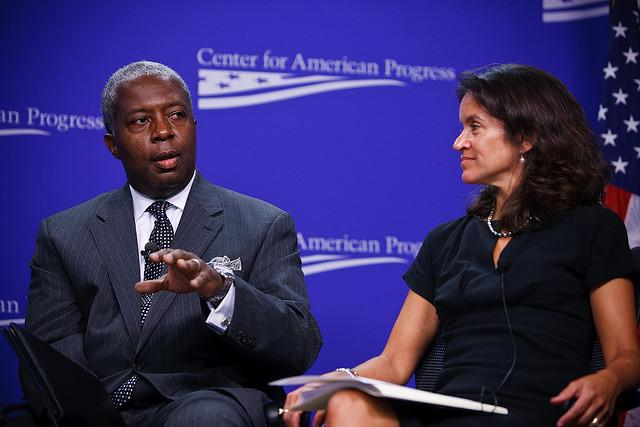What type talk is being given here? political 